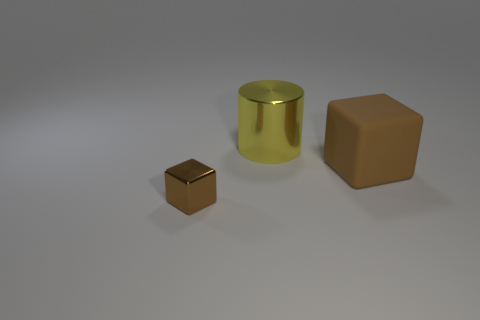Is there anything else that has the same size as the brown metal object?
Offer a very short reply. No. There is a thing that is to the right of the brown shiny object and in front of the large yellow shiny cylinder; what size is it?
Your answer should be very brief. Large. There is another thing that is the same shape as the brown rubber object; what is it made of?
Ensure brevity in your answer.  Metal. There is a object that is on the right side of the yellow metal cylinder behind the tiny brown metal object; what is its material?
Provide a succinct answer. Rubber. There is a small object; is its shape the same as the big thing in front of the big yellow shiny cylinder?
Your answer should be compact. Yes. How many rubber things are either tiny brown cubes or large brown blocks?
Make the answer very short. 1. What color is the metallic thing on the right side of the brown object that is on the left side of the brown cube to the right of the tiny shiny thing?
Ensure brevity in your answer.  Yellow. How many other objects are the same material as the big yellow thing?
Offer a very short reply. 1. Do the brown object on the right side of the tiny brown cube and the small brown shiny thing have the same shape?
Offer a terse response. Yes. How many small objects are either brown metallic cubes or matte objects?
Your answer should be compact. 1. 